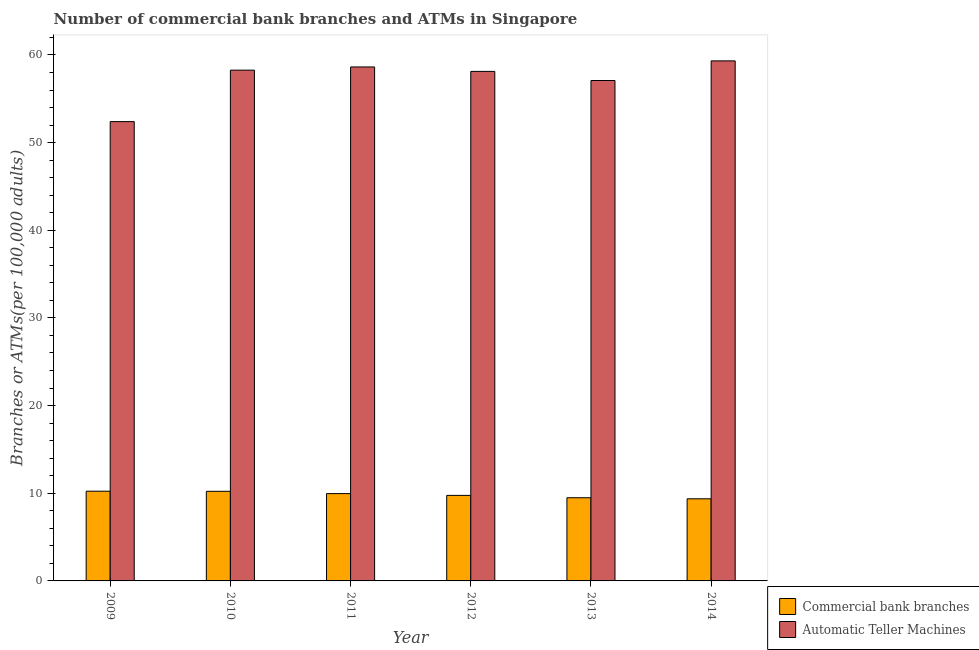How many different coloured bars are there?
Keep it short and to the point. 2. How many groups of bars are there?
Give a very brief answer. 6. Are the number of bars on each tick of the X-axis equal?
Your response must be concise. Yes. In how many cases, is the number of bars for a given year not equal to the number of legend labels?
Your response must be concise. 0. What is the number of commercal bank branches in 2010?
Offer a very short reply. 10.22. Across all years, what is the maximum number of commercal bank branches?
Your answer should be compact. 10.24. Across all years, what is the minimum number of atms?
Keep it short and to the point. 52.39. In which year was the number of commercal bank branches maximum?
Make the answer very short. 2009. In which year was the number of atms minimum?
Your response must be concise. 2009. What is the total number of atms in the graph?
Your answer should be very brief. 343.82. What is the difference between the number of atms in 2011 and that in 2012?
Provide a short and direct response. 0.51. What is the difference between the number of atms in 2013 and the number of commercal bank branches in 2010?
Your answer should be compact. -1.18. What is the average number of atms per year?
Your answer should be compact. 57.3. What is the ratio of the number of commercal bank branches in 2010 to that in 2012?
Your answer should be compact. 1.05. Is the number of commercal bank branches in 2010 less than that in 2012?
Your response must be concise. No. Is the difference between the number of atms in 2010 and 2012 greater than the difference between the number of commercal bank branches in 2010 and 2012?
Keep it short and to the point. No. What is the difference between the highest and the second highest number of commercal bank branches?
Your response must be concise. 0.01. What is the difference between the highest and the lowest number of commercal bank branches?
Your answer should be compact. 0.87. In how many years, is the number of commercal bank branches greater than the average number of commercal bank branches taken over all years?
Provide a succinct answer. 3. What does the 1st bar from the left in 2013 represents?
Your response must be concise. Commercial bank branches. What does the 2nd bar from the right in 2012 represents?
Ensure brevity in your answer.  Commercial bank branches. Are all the bars in the graph horizontal?
Keep it short and to the point. No. How many years are there in the graph?
Provide a succinct answer. 6. What is the difference between two consecutive major ticks on the Y-axis?
Offer a very short reply. 10. Does the graph contain grids?
Your answer should be very brief. No. Where does the legend appear in the graph?
Offer a terse response. Bottom right. What is the title of the graph?
Your response must be concise. Number of commercial bank branches and ATMs in Singapore. Does "Non-pregnant women" appear as one of the legend labels in the graph?
Ensure brevity in your answer.  No. What is the label or title of the Y-axis?
Your answer should be very brief. Branches or ATMs(per 100,0 adults). What is the Branches or ATMs(per 100,000 adults) of Commercial bank branches in 2009?
Offer a very short reply. 10.24. What is the Branches or ATMs(per 100,000 adults) in Automatic Teller Machines in 2009?
Give a very brief answer. 52.39. What is the Branches or ATMs(per 100,000 adults) in Commercial bank branches in 2010?
Your answer should be very brief. 10.22. What is the Branches or ATMs(per 100,000 adults) of Automatic Teller Machines in 2010?
Ensure brevity in your answer.  58.27. What is the Branches or ATMs(per 100,000 adults) of Commercial bank branches in 2011?
Make the answer very short. 9.96. What is the Branches or ATMs(per 100,000 adults) of Automatic Teller Machines in 2011?
Your answer should be compact. 58.63. What is the Branches or ATMs(per 100,000 adults) of Commercial bank branches in 2012?
Your answer should be very brief. 9.76. What is the Branches or ATMs(per 100,000 adults) in Automatic Teller Machines in 2012?
Your answer should be compact. 58.12. What is the Branches or ATMs(per 100,000 adults) of Commercial bank branches in 2013?
Ensure brevity in your answer.  9.49. What is the Branches or ATMs(per 100,000 adults) in Automatic Teller Machines in 2013?
Your response must be concise. 57.08. What is the Branches or ATMs(per 100,000 adults) of Commercial bank branches in 2014?
Your answer should be compact. 9.37. What is the Branches or ATMs(per 100,000 adults) in Automatic Teller Machines in 2014?
Offer a terse response. 59.32. Across all years, what is the maximum Branches or ATMs(per 100,000 adults) in Commercial bank branches?
Your answer should be compact. 10.24. Across all years, what is the maximum Branches or ATMs(per 100,000 adults) in Automatic Teller Machines?
Make the answer very short. 59.32. Across all years, what is the minimum Branches or ATMs(per 100,000 adults) in Commercial bank branches?
Offer a very short reply. 9.37. Across all years, what is the minimum Branches or ATMs(per 100,000 adults) of Automatic Teller Machines?
Keep it short and to the point. 52.39. What is the total Branches or ATMs(per 100,000 adults) in Commercial bank branches in the graph?
Provide a succinct answer. 59.03. What is the total Branches or ATMs(per 100,000 adults) in Automatic Teller Machines in the graph?
Offer a very short reply. 343.82. What is the difference between the Branches or ATMs(per 100,000 adults) of Commercial bank branches in 2009 and that in 2010?
Give a very brief answer. 0.01. What is the difference between the Branches or ATMs(per 100,000 adults) in Automatic Teller Machines in 2009 and that in 2010?
Give a very brief answer. -5.87. What is the difference between the Branches or ATMs(per 100,000 adults) of Commercial bank branches in 2009 and that in 2011?
Make the answer very short. 0.27. What is the difference between the Branches or ATMs(per 100,000 adults) of Automatic Teller Machines in 2009 and that in 2011?
Keep it short and to the point. -6.24. What is the difference between the Branches or ATMs(per 100,000 adults) in Commercial bank branches in 2009 and that in 2012?
Offer a terse response. 0.48. What is the difference between the Branches or ATMs(per 100,000 adults) in Automatic Teller Machines in 2009 and that in 2012?
Make the answer very short. -5.73. What is the difference between the Branches or ATMs(per 100,000 adults) in Commercial bank branches in 2009 and that in 2013?
Your response must be concise. 0.75. What is the difference between the Branches or ATMs(per 100,000 adults) in Automatic Teller Machines in 2009 and that in 2013?
Keep it short and to the point. -4.69. What is the difference between the Branches or ATMs(per 100,000 adults) of Commercial bank branches in 2009 and that in 2014?
Give a very brief answer. 0.87. What is the difference between the Branches or ATMs(per 100,000 adults) of Automatic Teller Machines in 2009 and that in 2014?
Ensure brevity in your answer.  -6.93. What is the difference between the Branches or ATMs(per 100,000 adults) of Commercial bank branches in 2010 and that in 2011?
Provide a short and direct response. 0.26. What is the difference between the Branches or ATMs(per 100,000 adults) of Automatic Teller Machines in 2010 and that in 2011?
Give a very brief answer. -0.36. What is the difference between the Branches or ATMs(per 100,000 adults) in Commercial bank branches in 2010 and that in 2012?
Offer a terse response. 0.46. What is the difference between the Branches or ATMs(per 100,000 adults) of Automatic Teller Machines in 2010 and that in 2012?
Ensure brevity in your answer.  0.14. What is the difference between the Branches or ATMs(per 100,000 adults) of Commercial bank branches in 2010 and that in 2013?
Ensure brevity in your answer.  0.74. What is the difference between the Branches or ATMs(per 100,000 adults) in Automatic Teller Machines in 2010 and that in 2013?
Provide a short and direct response. 1.18. What is the difference between the Branches or ATMs(per 100,000 adults) in Commercial bank branches in 2010 and that in 2014?
Offer a very short reply. 0.86. What is the difference between the Branches or ATMs(per 100,000 adults) of Automatic Teller Machines in 2010 and that in 2014?
Your response must be concise. -1.06. What is the difference between the Branches or ATMs(per 100,000 adults) of Commercial bank branches in 2011 and that in 2012?
Provide a short and direct response. 0.2. What is the difference between the Branches or ATMs(per 100,000 adults) in Automatic Teller Machines in 2011 and that in 2012?
Keep it short and to the point. 0.51. What is the difference between the Branches or ATMs(per 100,000 adults) in Commercial bank branches in 2011 and that in 2013?
Your answer should be very brief. 0.47. What is the difference between the Branches or ATMs(per 100,000 adults) in Automatic Teller Machines in 2011 and that in 2013?
Offer a very short reply. 1.55. What is the difference between the Branches or ATMs(per 100,000 adults) in Commercial bank branches in 2011 and that in 2014?
Provide a short and direct response. 0.59. What is the difference between the Branches or ATMs(per 100,000 adults) of Automatic Teller Machines in 2011 and that in 2014?
Keep it short and to the point. -0.69. What is the difference between the Branches or ATMs(per 100,000 adults) in Commercial bank branches in 2012 and that in 2013?
Your answer should be very brief. 0.27. What is the difference between the Branches or ATMs(per 100,000 adults) in Automatic Teller Machines in 2012 and that in 2013?
Your answer should be compact. 1.04. What is the difference between the Branches or ATMs(per 100,000 adults) of Commercial bank branches in 2012 and that in 2014?
Offer a terse response. 0.39. What is the difference between the Branches or ATMs(per 100,000 adults) of Automatic Teller Machines in 2012 and that in 2014?
Give a very brief answer. -1.2. What is the difference between the Branches or ATMs(per 100,000 adults) of Commercial bank branches in 2013 and that in 2014?
Provide a succinct answer. 0.12. What is the difference between the Branches or ATMs(per 100,000 adults) of Automatic Teller Machines in 2013 and that in 2014?
Your response must be concise. -2.24. What is the difference between the Branches or ATMs(per 100,000 adults) in Commercial bank branches in 2009 and the Branches or ATMs(per 100,000 adults) in Automatic Teller Machines in 2010?
Provide a short and direct response. -48.03. What is the difference between the Branches or ATMs(per 100,000 adults) of Commercial bank branches in 2009 and the Branches or ATMs(per 100,000 adults) of Automatic Teller Machines in 2011?
Your answer should be compact. -48.4. What is the difference between the Branches or ATMs(per 100,000 adults) in Commercial bank branches in 2009 and the Branches or ATMs(per 100,000 adults) in Automatic Teller Machines in 2012?
Offer a very short reply. -47.89. What is the difference between the Branches or ATMs(per 100,000 adults) in Commercial bank branches in 2009 and the Branches or ATMs(per 100,000 adults) in Automatic Teller Machines in 2013?
Give a very brief answer. -46.85. What is the difference between the Branches or ATMs(per 100,000 adults) in Commercial bank branches in 2009 and the Branches or ATMs(per 100,000 adults) in Automatic Teller Machines in 2014?
Ensure brevity in your answer.  -49.09. What is the difference between the Branches or ATMs(per 100,000 adults) of Commercial bank branches in 2010 and the Branches or ATMs(per 100,000 adults) of Automatic Teller Machines in 2011?
Your answer should be compact. -48.41. What is the difference between the Branches or ATMs(per 100,000 adults) of Commercial bank branches in 2010 and the Branches or ATMs(per 100,000 adults) of Automatic Teller Machines in 2012?
Provide a succinct answer. -47.9. What is the difference between the Branches or ATMs(per 100,000 adults) in Commercial bank branches in 2010 and the Branches or ATMs(per 100,000 adults) in Automatic Teller Machines in 2013?
Offer a very short reply. -46.86. What is the difference between the Branches or ATMs(per 100,000 adults) of Commercial bank branches in 2010 and the Branches or ATMs(per 100,000 adults) of Automatic Teller Machines in 2014?
Provide a succinct answer. -49.1. What is the difference between the Branches or ATMs(per 100,000 adults) of Commercial bank branches in 2011 and the Branches or ATMs(per 100,000 adults) of Automatic Teller Machines in 2012?
Keep it short and to the point. -48.16. What is the difference between the Branches or ATMs(per 100,000 adults) of Commercial bank branches in 2011 and the Branches or ATMs(per 100,000 adults) of Automatic Teller Machines in 2013?
Your answer should be compact. -47.12. What is the difference between the Branches or ATMs(per 100,000 adults) of Commercial bank branches in 2011 and the Branches or ATMs(per 100,000 adults) of Automatic Teller Machines in 2014?
Ensure brevity in your answer.  -49.36. What is the difference between the Branches or ATMs(per 100,000 adults) in Commercial bank branches in 2012 and the Branches or ATMs(per 100,000 adults) in Automatic Teller Machines in 2013?
Ensure brevity in your answer.  -47.32. What is the difference between the Branches or ATMs(per 100,000 adults) in Commercial bank branches in 2012 and the Branches or ATMs(per 100,000 adults) in Automatic Teller Machines in 2014?
Your answer should be very brief. -49.56. What is the difference between the Branches or ATMs(per 100,000 adults) of Commercial bank branches in 2013 and the Branches or ATMs(per 100,000 adults) of Automatic Teller Machines in 2014?
Offer a very short reply. -49.83. What is the average Branches or ATMs(per 100,000 adults) in Commercial bank branches per year?
Provide a succinct answer. 9.84. What is the average Branches or ATMs(per 100,000 adults) of Automatic Teller Machines per year?
Offer a terse response. 57.3. In the year 2009, what is the difference between the Branches or ATMs(per 100,000 adults) in Commercial bank branches and Branches or ATMs(per 100,000 adults) in Automatic Teller Machines?
Keep it short and to the point. -42.16. In the year 2010, what is the difference between the Branches or ATMs(per 100,000 adults) of Commercial bank branches and Branches or ATMs(per 100,000 adults) of Automatic Teller Machines?
Ensure brevity in your answer.  -48.04. In the year 2011, what is the difference between the Branches or ATMs(per 100,000 adults) in Commercial bank branches and Branches or ATMs(per 100,000 adults) in Automatic Teller Machines?
Provide a short and direct response. -48.67. In the year 2012, what is the difference between the Branches or ATMs(per 100,000 adults) of Commercial bank branches and Branches or ATMs(per 100,000 adults) of Automatic Teller Machines?
Provide a short and direct response. -48.36. In the year 2013, what is the difference between the Branches or ATMs(per 100,000 adults) in Commercial bank branches and Branches or ATMs(per 100,000 adults) in Automatic Teller Machines?
Give a very brief answer. -47.59. In the year 2014, what is the difference between the Branches or ATMs(per 100,000 adults) of Commercial bank branches and Branches or ATMs(per 100,000 adults) of Automatic Teller Machines?
Your answer should be very brief. -49.96. What is the ratio of the Branches or ATMs(per 100,000 adults) of Commercial bank branches in 2009 to that in 2010?
Provide a short and direct response. 1. What is the ratio of the Branches or ATMs(per 100,000 adults) in Automatic Teller Machines in 2009 to that in 2010?
Offer a very short reply. 0.9. What is the ratio of the Branches or ATMs(per 100,000 adults) of Commercial bank branches in 2009 to that in 2011?
Make the answer very short. 1.03. What is the ratio of the Branches or ATMs(per 100,000 adults) in Automatic Teller Machines in 2009 to that in 2011?
Offer a terse response. 0.89. What is the ratio of the Branches or ATMs(per 100,000 adults) of Commercial bank branches in 2009 to that in 2012?
Keep it short and to the point. 1.05. What is the ratio of the Branches or ATMs(per 100,000 adults) of Automatic Teller Machines in 2009 to that in 2012?
Your answer should be very brief. 0.9. What is the ratio of the Branches or ATMs(per 100,000 adults) in Commercial bank branches in 2009 to that in 2013?
Offer a terse response. 1.08. What is the ratio of the Branches or ATMs(per 100,000 adults) in Automatic Teller Machines in 2009 to that in 2013?
Provide a short and direct response. 0.92. What is the ratio of the Branches or ATMs(per 100,000 adults) of Commercial bank branches in 2009 to that in 2014?
Your response must be concise. 1.09. What is the ratio of the Branches or ATMs(per 100,000 adults) of Automatic Teller Machines in 2009 to that in 2014?
Keep it short and to the point. 0.88. What is the ratio of the Branches or ATMs(per 100,000 adults) of Commercial bank branches in 2010 to that in 2011?
Provide a short and direct response. 1.03. What is the ratio of the Branches or ATMs(per 100,000 adults) in Commercial bank branches in 2010 to that in 2012?
Your answer should be very brief. 1.05. What is the ratio of the Branches or ATMs(per 100,000 adults) of Automatic Teller Machines in 2010 to that in 2012?
Give a very brief answer. 1. What is the ratio of the Branches or ATMs(per 100,000 adults) of Commercial bank branches in 2010 to that in 2013?
Ensure brevity in your answer.  1.08. What is the ratio of the Branches or ATMs(per 100,000 adults) in Automatic Teller Machines in 2010 to that in 2013?
Ensure brevity in your answer.  1.02. What is the ratio of the Branches or ATMs(per 100,000 adults) of Commercial bank branches in 2010 to that in 2014?
Provide a short and direct response. 1.09. What is the ratio of the Branches or ATMs(per 100,000 adults) in Automatic Teller Machines in 2010 to that in 2014?
Ensure brevity in your answer.  0.98. What is the ratio of the Branches or ATMs(per 100,000 adults) in Commercial bank branches in 2011 to that in 2012?
Your answer should be compact. 1.02. What is the ratio of the Branches or ATMs(per 100,000 adults) of Automatic Teller Machines in 2011 to that in 2012?
Ensure brevity in your answer.  1.01. What is the ratio of the Branches or ATMs(per 100,000 adults) in Commercial bank branches in 2011 to that in 2013?
Offer a terse response. 1.05. What is the ratio of the Branches or ATMs(per 100,000 adults) in Automatic Teller Machines in 2011 to that in 2013?
Offer a terse response. 1.03. What is the ratio of the Branches or ATMs(per 100,000 adults) of Commercial bank branches in 2011 to that in 2014?
Ensure brevity in your answer.  1.06. What is the ratio of the Branches or ATMs(per 100,000 adults) of Automatic Teller Machines in 2011 to that in 2014?
Provide a short and direct response. 0.99. What is the ratio of the Branches or ATMs(per 100,000 adults) in Commercial bank branches in 2012 to that in 2013?
Offer a very short reply. 1.03. What is the ratio of the Branches or ATMs(per 100,000 adults) in Automatic Teller Machines in 2012 to that in 2013?
Give a very brief answer. 1.02. What is the ratio of the Branches or ATMs(per 100,000 adults) in Commercial bank branches in 2012 to that in 2014?
Your answer should be very brief. 1.04. What is the ratio of the Branches or ATMs(per 100,000 adults) in Automatic Teller Machines in 2012 to that in 2014?
Ensure brevity in your answer.  0.98. What is the ratio of the Branches or ATMs(per 100,000 adults) in Commercial bank branches in 2013 to that in 2014?
Make the answer very short. 1.01. What is the ratio of the Branches or ATMs(per 100,000 adults) of Automatic Teller Machines in 2013 to that in 2014?
Provide a short and direct response. 0.96. What is the difference between the highest and the second highest Branches or ATMs(per 100,000 adults) of Commercial bank branches?
Your answer should be compact. 0.01. What is the difference between the highest and the second highest Branches or ATMs(per 100,000 adults) of Automatic Teller Machines?
Your response must be concise. 0.69. What is the difference between the highest and the lowest Branches or ATMs(per 100,000 adults) in Commercial bank branches?
Your answer should be very brief. 0.87. What is the difference between the highest and the lowest Branches or ATMs(per 100,000 adults) in Automatic Teller Machines?
Make the answer very short. 6.93. 